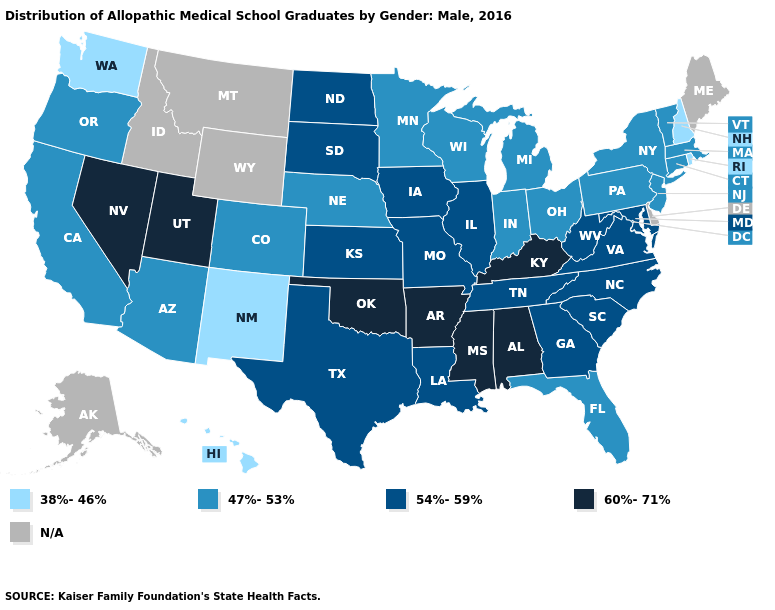Name the states that have a value in the range 38%-46%?
Be succinct. Hawaii, New Hampshire, New Mexico, Rhode Island, Washington. Does the first symbol in the legend represent the smallest category?
Short answer required. Yes. Name the states that have a value in the range 47%-53%?
Keep it brief. Arizona, California, Colorado, Connecticut, Florida, Indiana, Massachusetts, Michigan, Minnesota, Nebraska, New Jersey, New York, Ohio, Oregon, Pennsylvania, Vermont, Wisconsin. Which states have the lowest value in the MidWest?
Concise answer only. Indiana, Michigan, Minnesota, Nebraska, Ohio, Wisconsin. What is the lowest value in states that border New York?
Write a very short answer. 47%-53%. Does the map have missing data?
Quick response, please. Yes. What is the value of Oregon?
Write a very short answer. 47%-53%. Which states have the highest value in the USA?
Quick response, please. Alabama, Arkansas, Kentucky, Mississippi, Nevada, Oklahoma, Utah. What is the value of Hawaii?
Short answer required. 38%-46%. Does North Carolina have the highest value in the USA?
Answer briefly. No. Is the legend a continuous bar?
Concise answer only. No. What is the lowest value in the USA?
Answer briefly. 38%-46%. What is the highest value in the MidWest ?
Concise answer only. 54%-59%. What is the value of Missouri?
Short answer required. 54%-59%. 